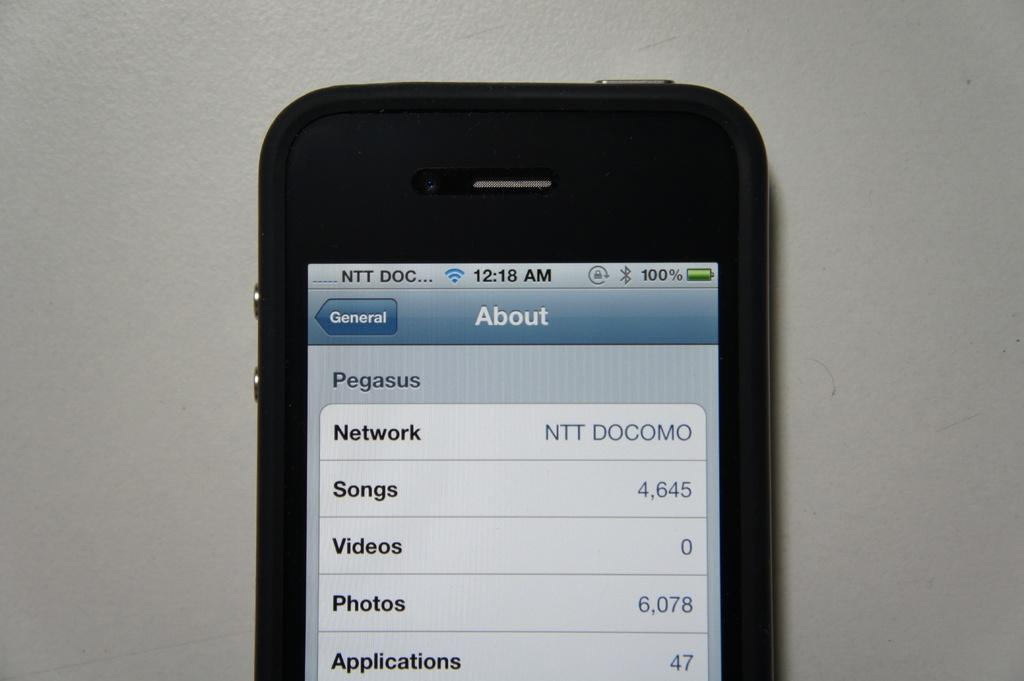<image>
Render a clear and concise summary of the photo. A cellphone turned to the About page shows the time as 12:18 AM. 